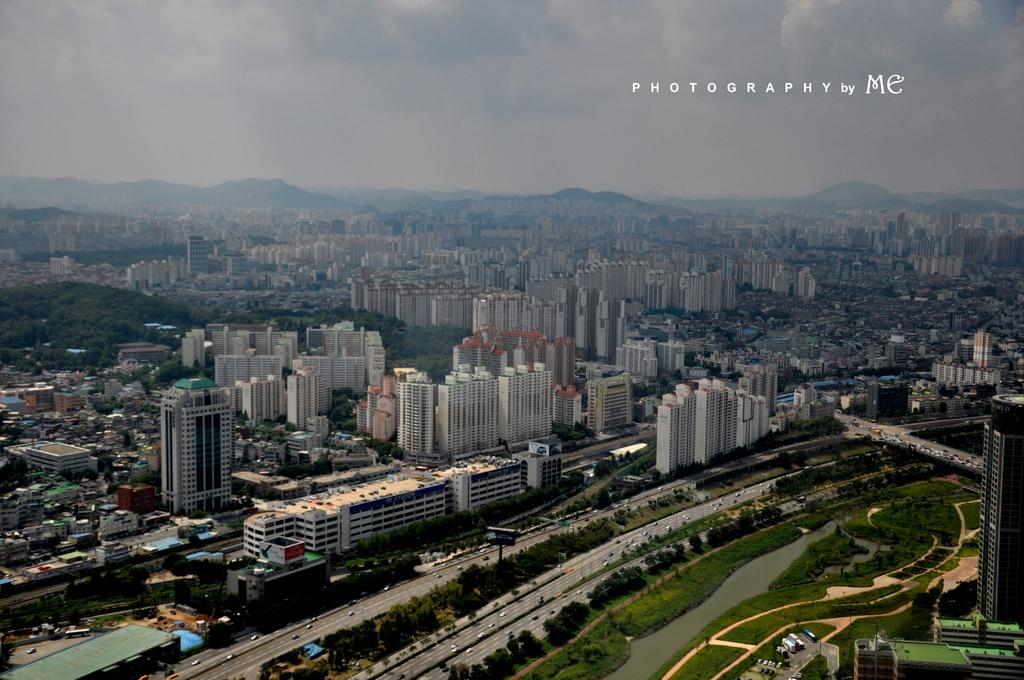What type of structures can be seen in the image? There are buildings in the image. What natural element is visible in the image? There is water visible in the image. What type of vegetation is present in the image? There are plants and trees in the image. What man-made structures can be seen in the image? There are roads in the image. What are the vehicles in the image used for? The vehicles in the image are used for transportation. What type of terrain is visible in the image? There are hills in the image. What part of the environment is visible in the image? The sky is visible in the image. Where is the toothbrush located in the image? There is no toothbrush present in the image. How many giants can be seen in the image? There are no giants present in the image. 